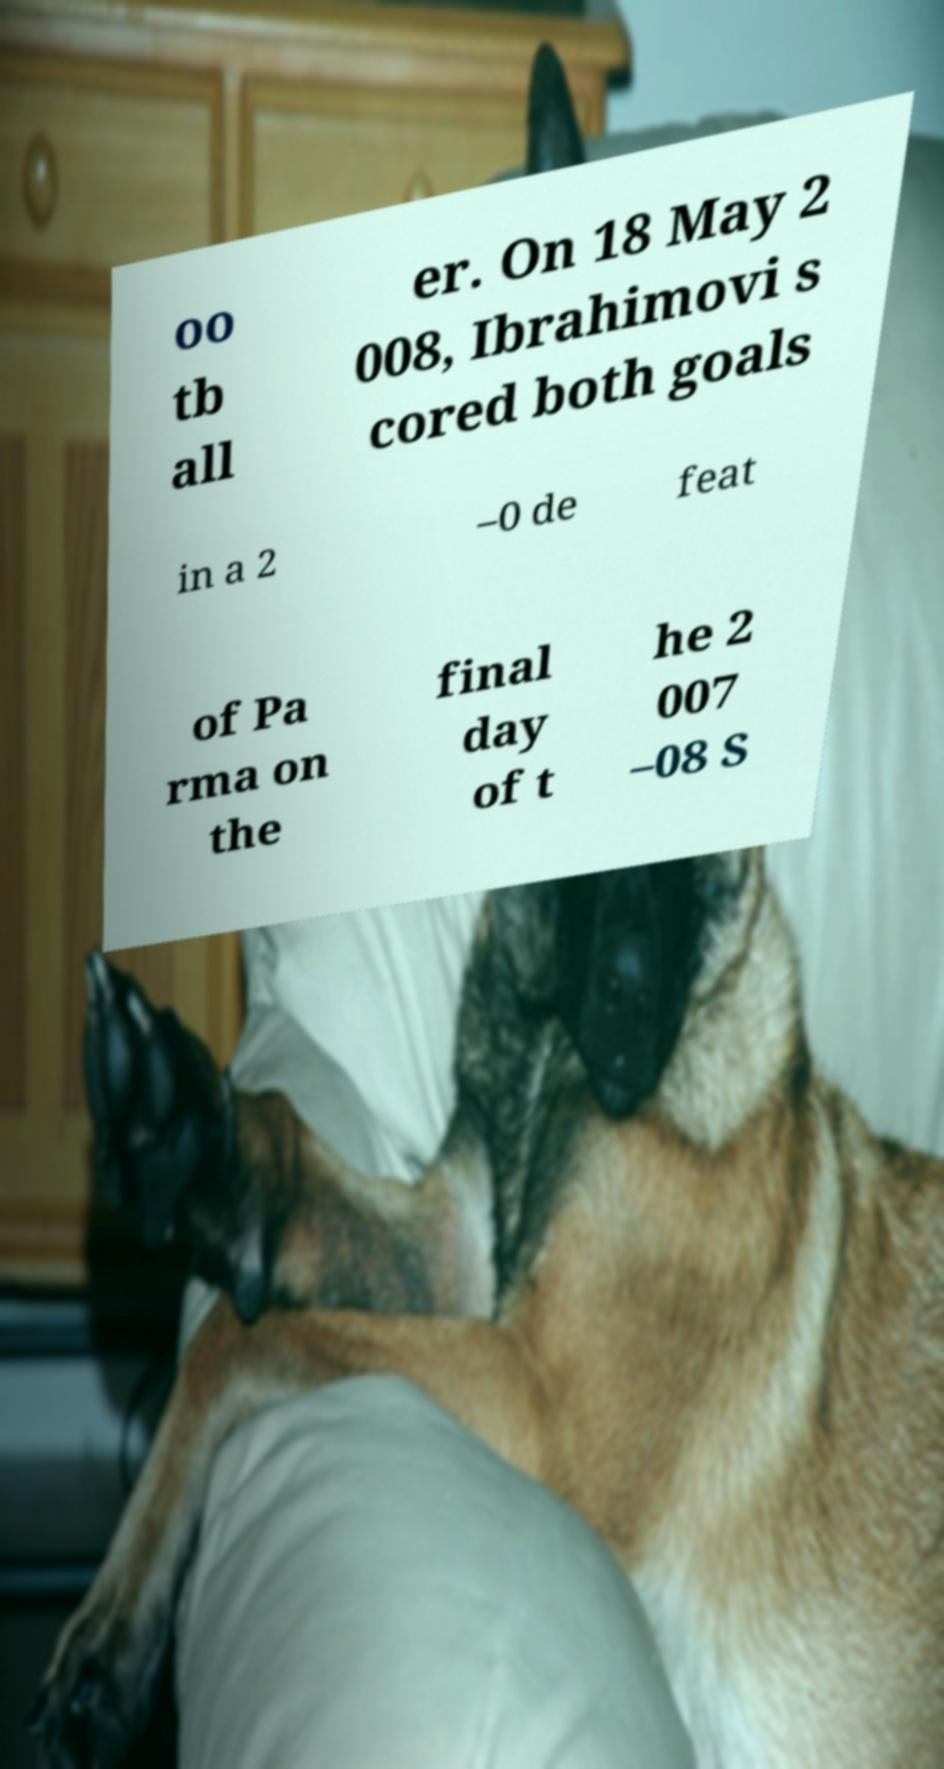Please identify and transcribe the text found in this image. oo tb all er. On 18 May 2 008, Ibrahimovi s cored both goals in a 2 –0 de feat of Pa rma on the final day of t he 2 007 –08 S 